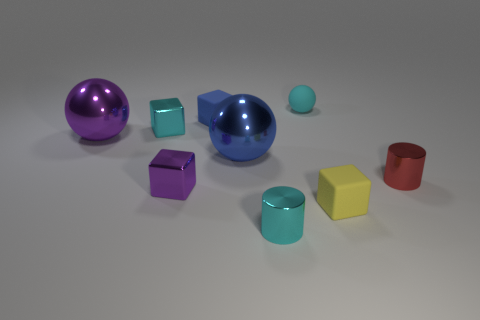Subtract 1 cubes. How many cubes are left? 3 Add 1 small rubber objects. How many objects exist? 10 Subtract all cylinders. How many objects are left? 7 Add 4 small blue cubes. How many small blue cubes exist? 5 Subtract 0 brown cylinders. How many objects are left? 9 Subtract all small green objects. Subtract all small blue blocks. How many objects are left? 8 Add 6 cyan cylinders. How many cyan cylinders are left? 7 